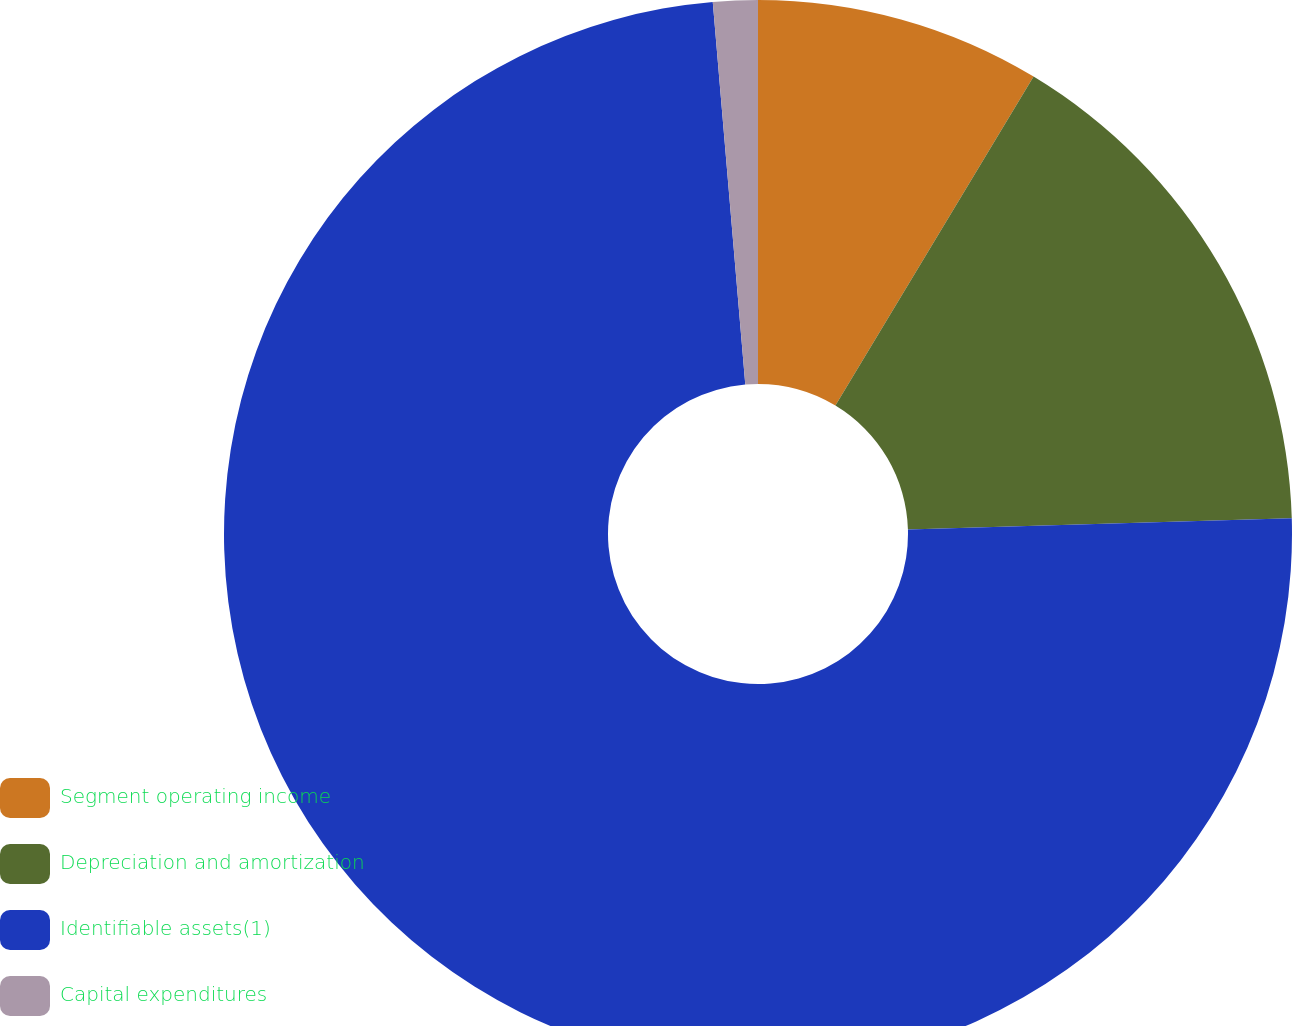Convert chart. <chart><loc_0><loc_0><loc_500><loc_500><pie_chart><fcel>Segment operating income<fcel>Depreciation and amortization<fcel>Identifiable assets(1)<fcel>Capital expenditures<nl><fcel>8.63%<fcel>15.9%<fcel>74.11%<fcel>1.35%<nl></chart> 